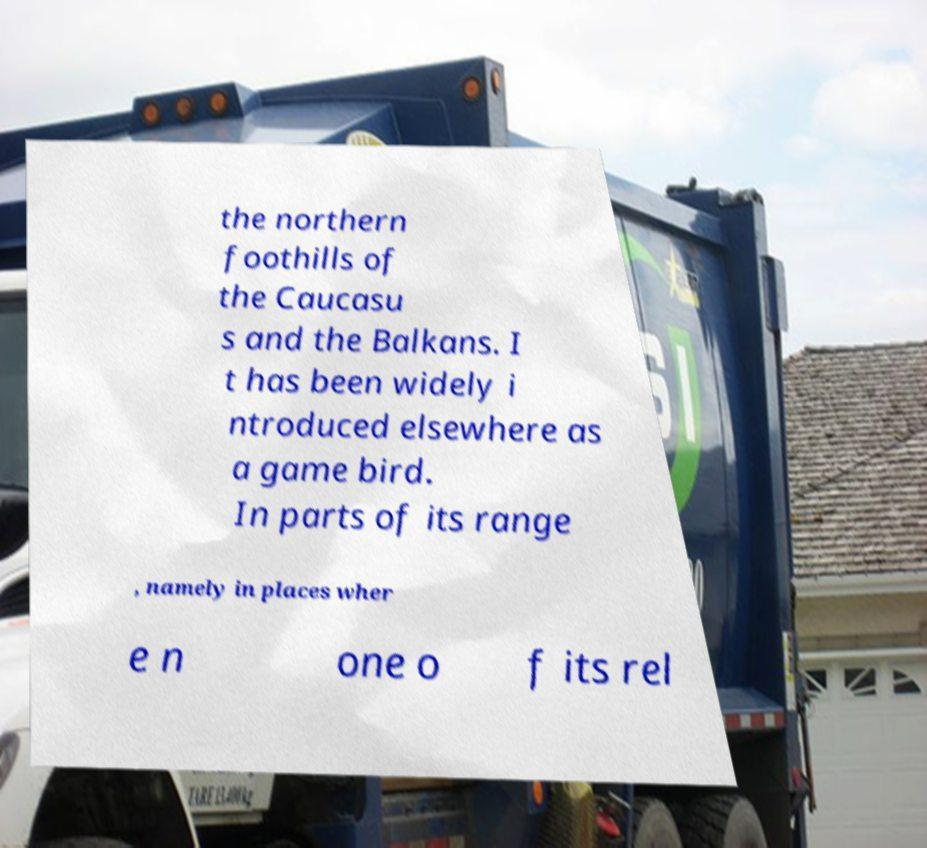Please read and relay the text visible in this image. What does it say? the northern foothills of the Caucasu s and the Balkans. I t has been widely i ntroduced elsewhere as a game bird. In parts of its range , namely in places wher e n one o f its rel 